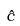<formula> <loc_0><loc_0><loc_500><loc_500>\hat { c }</formula> 